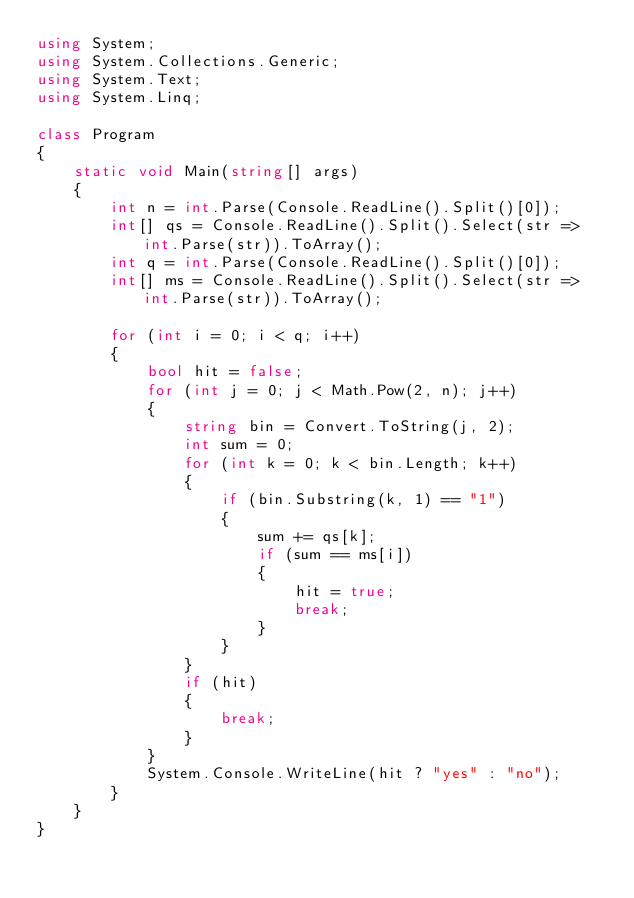Convert code to text. <code><loc_0><loc_0><loc_500><loc_500><_C#_>using System;
using System.Collections.Generic;
using System.Text;
using System.Linq;

class Program
{
	static void Main(string[] args)
	{
		int n = int.Parse(Console.ReadLine().Split()[0]);
		int[] qs = Console.ReadLine().Split().Select(str => int.Parse(str)).ToArray();
		int q = int.Parse(Console.ReadLine().Split()[0]);
		int[] ms = Console.ReadLine().Split().Select(str => int.Parse(str)).ToArray();

		for (int i = 0; i < q; i++)
		{
			bool hit = false;
			for (int j = 0; j < Math.Pow(2, n); j++)
			{
				string bin = Convert.ToString(j, 2);
				int sum = 0;
				for (int k = 0; k < bin.Length; k++)
				{
					if (bin.Substring(k, 1) == "1")
					{
						sum += qs[k];
						if (sum == ms[i])
						{
							hit = true;
							break;
						}
					}
				}
				if (hit)
				{
					break;
				}
			}
			System.Console.WriteLine(hit ? "yes" : "no");
		}
	}
}

</code> 